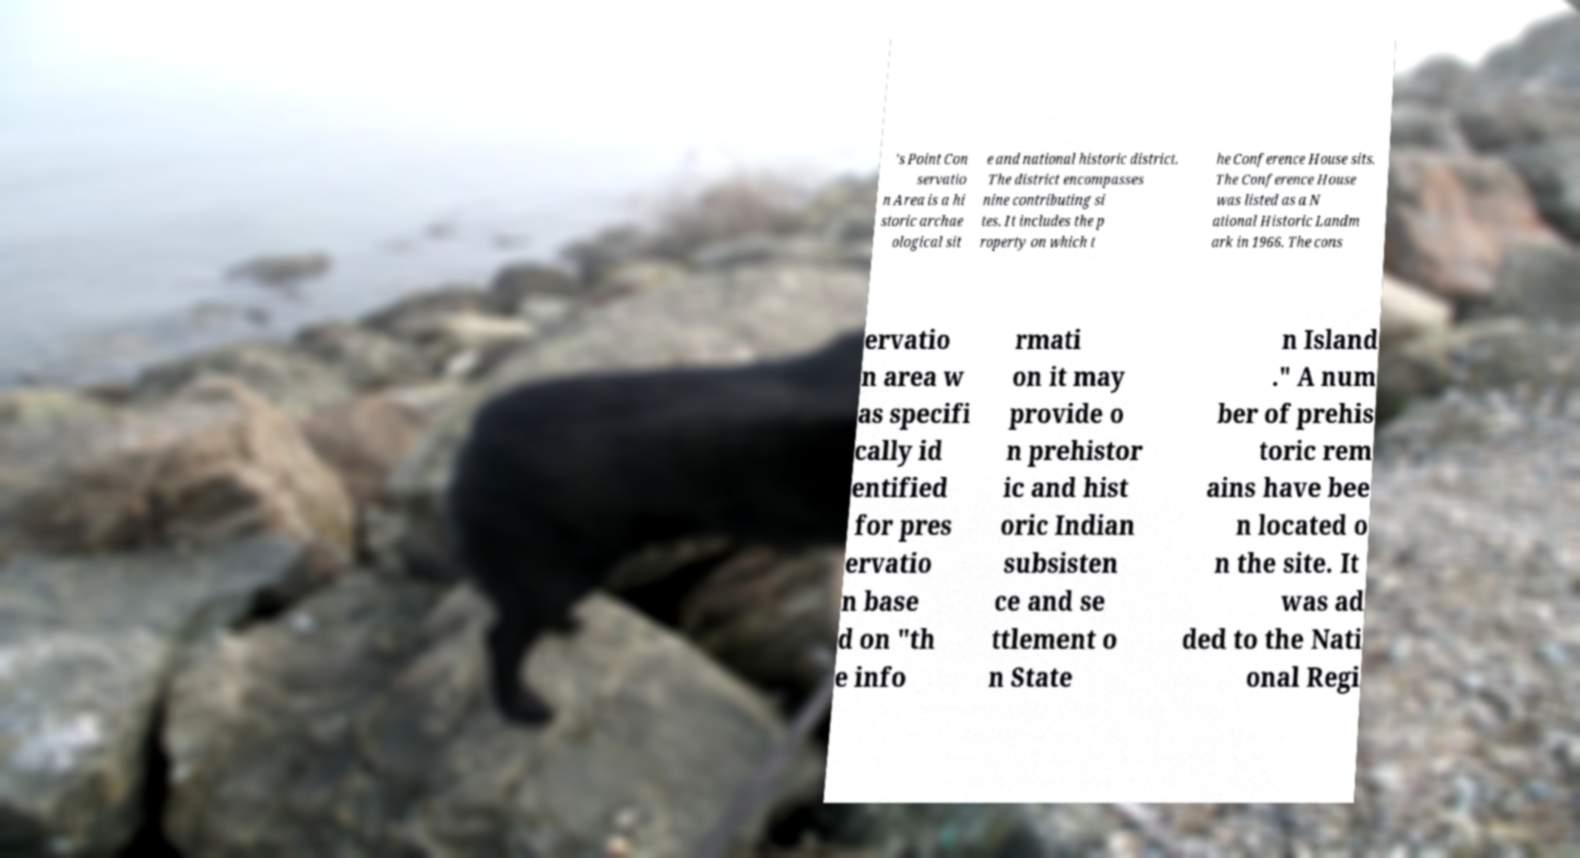What messages or text are displayed in this image? I need them in a readable, typed format. 's Point Con servatio n Area is a hi storic archae ological sit e and national historic district. The district encompasses nine contributing si tes. It includes the p roperty on which t he Conference House sits. The Conference House was listed as a N ational Historic Landm ark in 1966. The cons ervatio n area w as specifi cally id entified for pres ervatio n base d on "th e info rmati on it may provide o n prehistor ic and hist oric Indian subsisten ce and se ttlement o n State n Island ." A num ber of prehis toric rem ains have bee n located o n the site. It was ad ded to the Nati onal Regi 